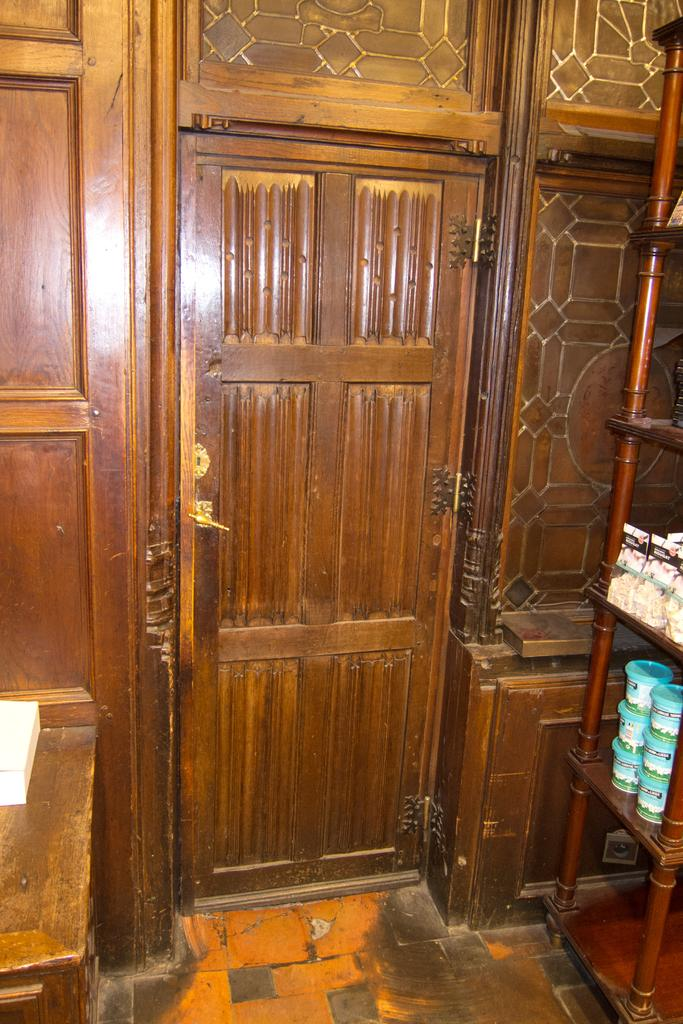What type of door is visible in the image? There is a wooden door in the image. To which structure does the door belong? The door belongs to a building. What can be seen beside the door in the image? There is a rack with objects arranged beside the door. How does the door contribute to the journey of the people inside the building? The door does not contribute to the journey of the people inside the building; it is a stationary object used for entering and exiting the building. 